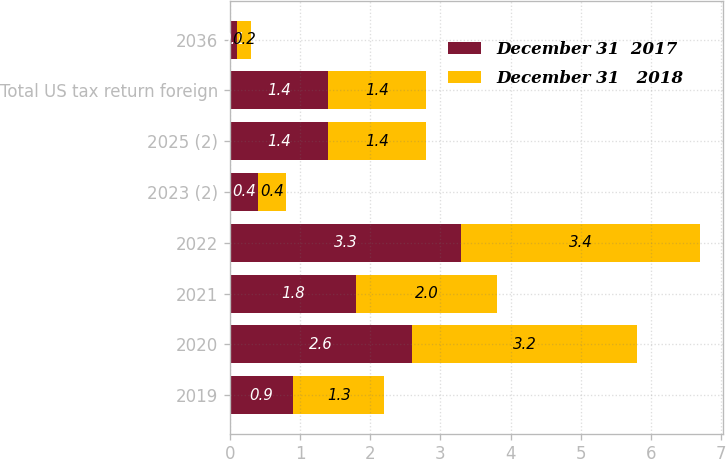Convert chart to OTSL. <chart><loc_0><loc_0><loc_500><loc_500><stacked_bar_chart><ecel><fcel>2019<fcel>2020<fcel>2021<fcel>2022<fcel>2023 (2)<fcel>2025 (2)<fcel>Total US tax return foreign<fcel>2036<nl><fcel>December 31  2017<fcel>0.9<fcel>2.6<fcel>1.8<fcel>3.3<fcel>0.4<fcel>1.4<fcel>1.4<fcel>0.1<nl><fcel>December 31   2018<fcel>1.3<fcel>3.2<fcel>2<fcel>3.4<fcel>0.4<fcel>1.4<fcel>1.4<fcel>0.2<nl></chart> 